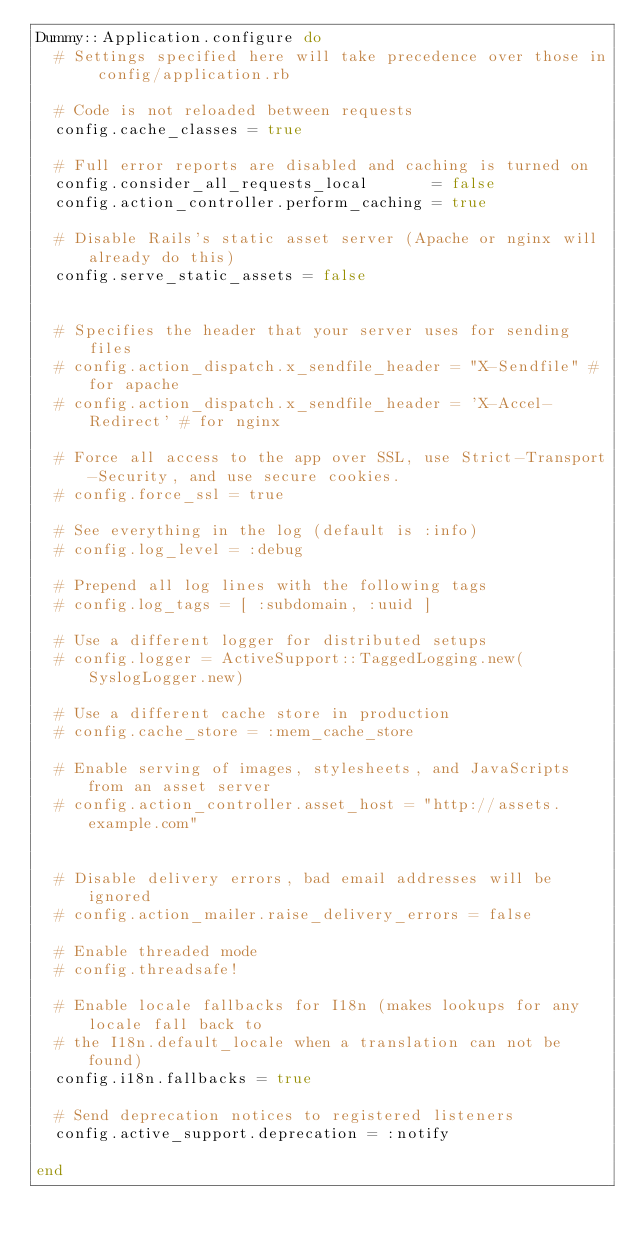Convert code to text. <code><loc_0><loc_0><loc_500><loc_500><_Ruby_>Dummy::Application.configure do
  # Settings specified here will take precedence over those in config/application.rb

  # Code is not reloaded between requests
  config.cache_classes = true

  # Full error reports are disabled and caching is turned on
  config.consider_all_requests_local       = false
  config.action_controller.perform_caching = true

  # Disable Rails's static asset server (Apache or nginx will already do this)
  config.serve_static_assets = false


  # Specifies the header that your server uses for sending files
  # config.action_dispatch.x_sendfile_header = "X-Sendfile" # for apache
  # config.action_dispatch.x_sendfile_header = 'X-Accel-Redirect' # for nginx

  # Force all access to the app over SSL, use Strict-Transport-Security, and use secure cookies.
  # config.force_ssl = true

  # See everything in the log (default is :info)
  # config.log_level = :debug

  # Prepend all log lines with the following tags
  # config.log_tags = [ :subdomain, :uuid ]

  # Use a different logger for distributed setups
  # config.logger = ActiveSupport::TaggedLogging.new(SyslogLogger.new)

  # Use a different cache store in production
  # config.cache_store = :mem_cache_store

  # Enable serving of images, stylesheets, and JavaScripts from an asset server
  # config.action_controller.asset_host = "http://assets.example.com"


  # Disable delivery errors, bad email addresses will be ignored
  # config.action_mailer.raise_delivery_errors = false

  # Enable threaded mode
  # config.threadsafe!

  # Enable locale fallbacks for I18n (makes lookups for any locale fall back to
  # the I18n.default_locale when a translation can not be found)
  config.i18n.fallbacks = true

  # Send deprecation notices to registered listeners
  config.active_support.deprecation = :notify

end
</code> 